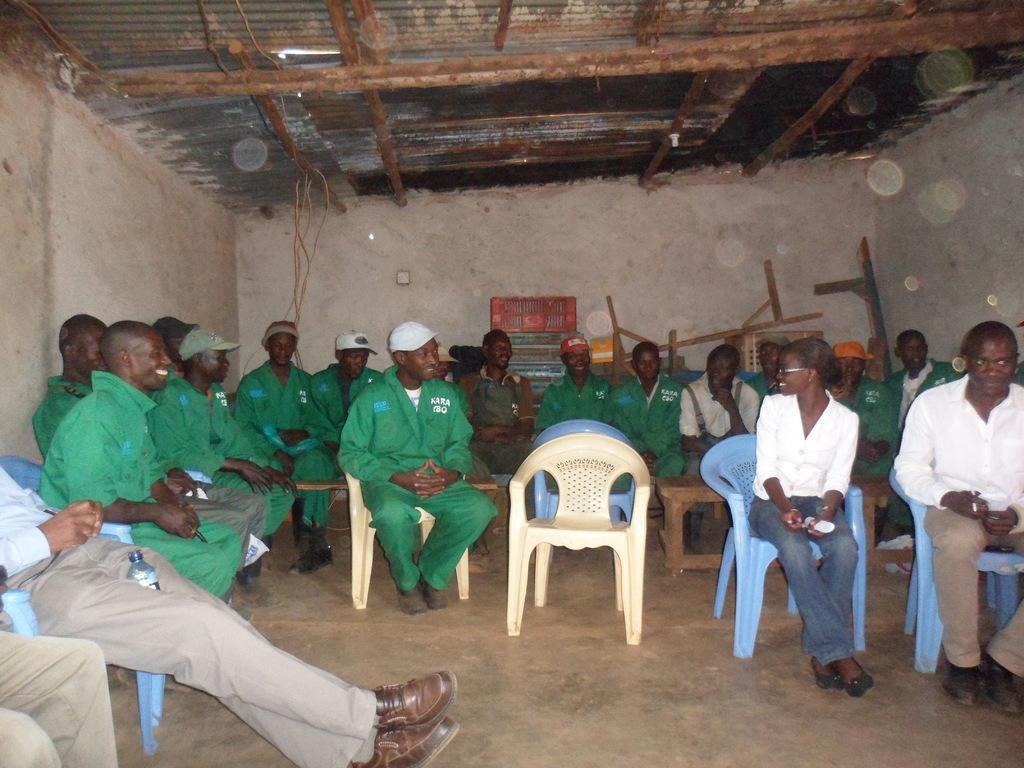How would you summarize this image in a sentence or two? In this image we can see a group of persons are sitting on the chair, and here is the wall, and here is the roof. 